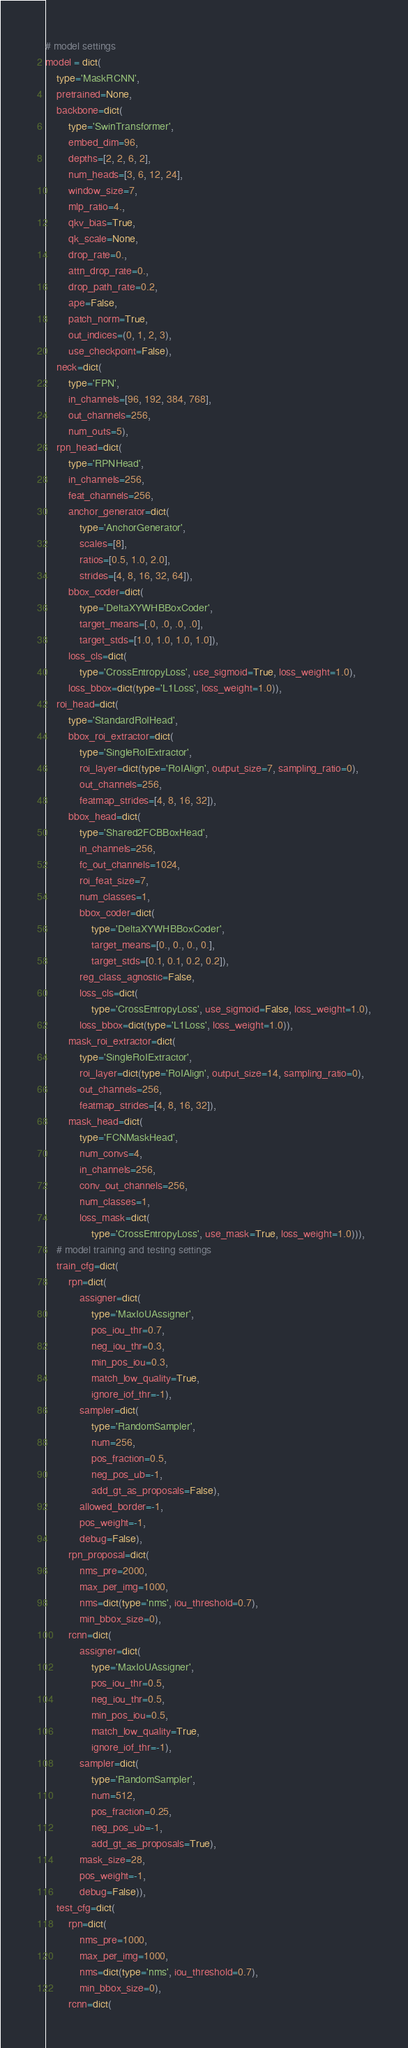<code> <loc_0><loc_0><loc_500><loc_500><_Python_># model settings
model = dict(
    type='MaskRCNN',
    pretrained=None,
    backbone=dict(
        type='SwinTransformer',
        embed_dim=96,
        depths=[2, 2, 6, 2],
        num_heads=[3, 6, 12, 24],
        window_size=7,
        mlp_ratio=4.,
        qkv_bias=True,
        qk_scale=None,
        drop_rate=0.,
        attn_drop_rate=0.,
        drop_path_rate=0.2,
        ape=False,
        patch_norm=True,
        out_indices=(0, 1, 2, 3),
        use_checkpoint=False),
    neck=dict(
        type='FPN',
        in_channels=[96, 192, 384, 768],
        out_channels=256,
        num_outs=5),
    rpn_head=dict(
        type='RPNHead',
        in_channels=256,
        feat_channels=256,
        anchor_generator=dict(
            type='AnchorGenerator',
            scales=[8],
            ratios=[0.5, 1.0, 2.0],
            strides=[4, 8, 16, 32, 64]),
        bbox_coder=dict(
            type='DeltaXYWHBBoxCoder',
            target_means=[.0, .0, .0, .0],
            target_stds=[1.0, 1.0, 1.0, 1.0]),
        loss_cls=dict(
            type='CrossEntropyLoss', use_sigmoid=True, loss_weight=1.0),
        loss_bbox=dict(type='L1Loss', loss_weight=1.0)),
    roi_head=dict(
        type='StandardRoIHead',
        bbox_roi_extractor=dict(
            type='SingleRoIExtractor',
            roi_layer=dict(type='RoIAlign', output_size=7, sampling_ratio=0),
            out_channels=256,
            featmap_strides=[4, 8, 16, 32]),
        bbox_head=dict(
            type='Shared2FCBBoxHead',
            in_channels=256,
            fc_out_channels=1024,
            roi_feat_size=7,
            num_classes=1,
            bbox_coder=dict(
                type='DeltaXYWHBBoxCoder',
                target_means=[0., 0., 0., 0.],
                target_stds=[0.1, 0.1, 0.2, 0.2]),
            reg_class_agnostic=False,
            loss_cls=dict(
                type='CrossEntropyLoss', use_sigmoid=False, loss_weight=1.0),
            loss_bbox=dict(type='L1Loss', loss_weight=1.0)),
        mask_roi_extractor=dict(
            type='SingleRoIExtractor',
            roi_layer=dict(type='RoIAlign', output_size=14, sampling_ratio=0),
            out_channels=256,
            featmap_strides=[4, 8, 16, 32]),
        mask_head=dict(
            type='FCNMaskHead',
            num_convs=4,
            in_channels=256,
            conv_out_channels=256,
            num_classes=1,
            loss_mask=dict(
                type='CrossEntropyLoss', use_mask=True, loss_weight=1.0))),
    # model training and testing settings
    train_cfg=dict(
        rpn=dict(
            assigner=dict(
                type='MaxIoUAssigner',
                pos_iou_thr=0.7,
                neg_iou_thr=0.3,
                min_pos_iou=0.3,
                match_low_quality=True,
                ignore_iof_thr=-1),
            sampler=dict(
                type='RandomSampler',
                num=256,
                pos_fraction=0.5,
                neg_pos_ub=-1,
                add_gt_as_proposals=False),
            allowed_border=-1,
            pos_weight=-1,
            debug=False),
        rpn_proposal=dict(
            nms_pre=2000,
            max_per_img=1000,
            nms=dict(type='nms', iou_threshold=0.7),
            min_bbox_size=0),
        rcnn=dict(
            assigner=dict(
                type='MaxIoUAssigner',
                pos_iou_thr=0.5,
                neg_iou_thr=0.5,
                min_pos_iou=0.5,
                match_low_quality=True,
                ignore_iof_thr=-1),
            sampler=dict(
                type='RandomSampler',
                num=512,
                pos_fraction=0.25,
                neg_pos_ub=-1,
                add_gt_as_proposals=True),
            mask_size=28,
            pos_weight=-1,
            debug=False)),
    test_cfg=dict(
        rpn=dict(
            nms_pre=1000,
            max_per_img=1000,
            nms=dict(type='nms', iou_threshold=0.7),
            min_bbox_size=0),
        rcnn=dict(</code> 